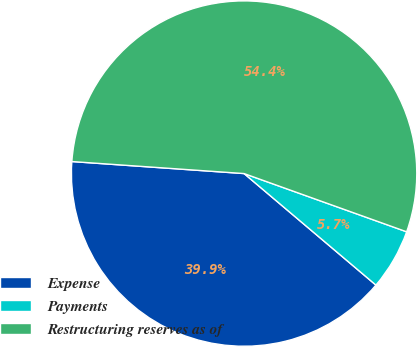Convert chart. <chart><loc_0><loc_0><loc_500><loc_500><pie_chart><fcel>Expense<fcel>Payments<fcel>Restructuring reserves as of<nl><fcel>39.93%<fcel>5.7%<fcel>54.36%<nl></chart> 